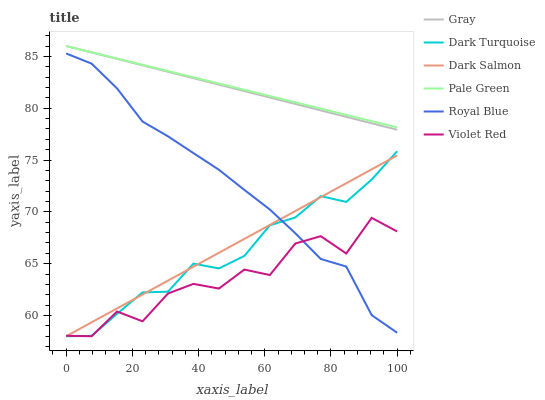Does Violet Red have the minimum area under the curve?
Answer yes or no. Yes. Does Pale Green have the maximum area under the curve?
Answer yes or no. Yes. Does Dark Turquoise have the minimum area under the curve?
Answer yes or no. No. Does Dark Turquoise have the maximum area under the curve?
Answer yes or no. No. Is Gray the smoothest?
Answer yes or no. Yes. Is Violet Red the roughest?
Answer yes or no. Yes. Is Dark Turquoise the smoothest?
Answer yes or no. No. Is Dark Turquoise the roughest?
Answer yes or no. No. Does Violet Red have the lowest value?
Answer yes or no. Yes. Does Royal Blue have the lowest value?
Answer yes or no. No. Does Pale Green have the highest value?
Answer yes or no. Yes. Does Dark Turquoise have the highest value?
Answer yes or no. No. Is Violet Red less than Gray?
Answer yes or no. Yes. Is Gray greater than Violet Red?
Answer yes or no. Yes. Does Pale Green intersect Gray?
Answer yes or no. Yes. Is Pale Green less than Gray?
Answer yes or no. No. Is Pale Green greater than Gray?
Answer yes or no. No. Does Violet Red intersect Gray?
Answer yes or no. No. 